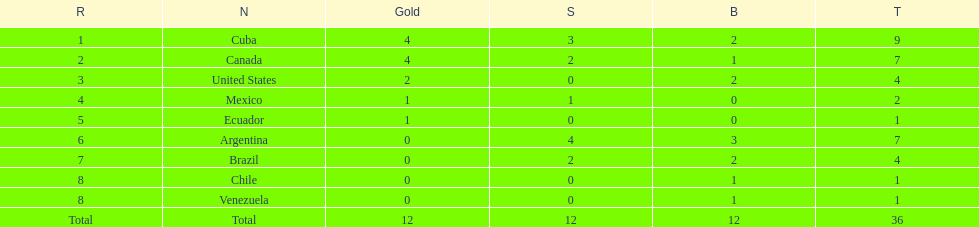Write the full table. {'header': ['R', 'N', 'Gold', 'S', 'B', 'T'], 'rows': [['1', 'Cuba', '4', '3', '2', '9'], ['2', 'Canada', '4', '2', '1', '7'], ['3', 'United States', '2', '0', '2', '4'], ['4', 'Mexico', '1', '1', '0', '2'], ['5', 'Ecuador', '1', '0', '0', '1'], ['6', 'Argentina', '0', '4', '3', '7'], ['7', 'Brazil', '0', '2', '2', '4'], ['8', 'Chile', '0', '0', '1', '1'], ['8', 'Venezuela', '0', '0', '1', '1'], ['Total', 'Total', '12', '12', '12', '36']]} Which is the only nation to win a gold medal and nothing else? Ecuador. 